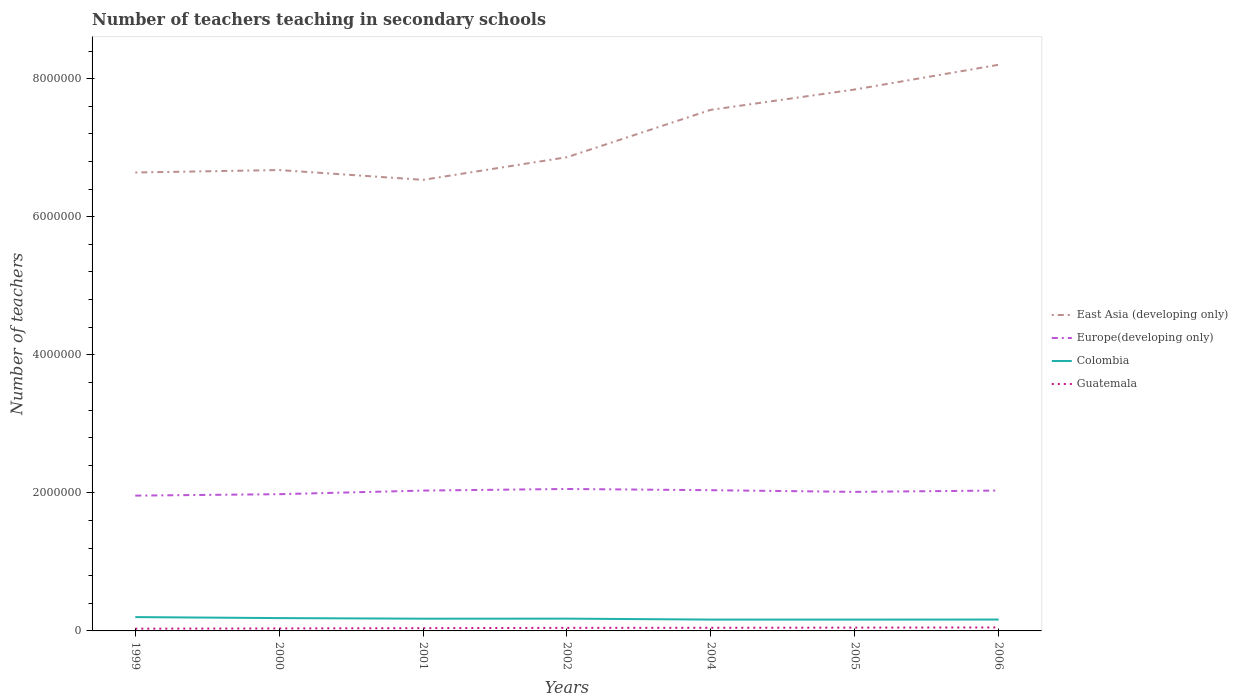Does the line corresponding to Europe(developing only) intersect with the line corresponding to Colombia?
Offer a very short reply. No. Across all years, what is the maximum number of teachers teaching in secondary schools in Colombia?
Keep it short and to the point. 1.64e+05. What is the total number of teachers teaching in secondary schools in Guatemala in the graph?
Your answer should be compact. -9490. What is the difference between the highest and the second highest number of teachers teaching in secondary schools in Guatemala?
Your answer should be compact. 1.71e+04. What is the difference between the highest and the lowest number of teachers teaching in secondary schools in Europe(developing only)?
Your response must be concise. 4. How many lines are there?
Your answer should be very brief. 4. How many years are there in the graph?
Offer a terse response. 7. What is the difference between two consecutive major ticks on the Y-axis?
Your response must be concise. 2.00e+06. Are the values on the major ticks of Y-axis written in scientific E-notation?
Make the answer very short. No. How many legend labels are there?
Your response must be concise. 4. How are the legend labels stacked?
Ensure brevity in your answer.  Vertical. What is the title of the graph?
Make the answer very short. Number of teachers teaching in secondary schools. Does "Middle East & North Africa (all income levels)" appear as one of the legend labels in the graph?
Your answer should be very brief. No. What is the label or title of the X-axis?
Offer a terse response. Years. What is the label or title of the Y-axis?
Your answer should be very brief. Number of teachers. What is the Number of teachers of East Asia (developing only) in 1999?
Offer a terse response. 6.64e+06. What is the Number of teachers of Europe(developing only) in 1999?
Your answer should be compact. 1.96e+06. What is the Number of teachers of Colombia in 1999?
Give a very brief answer. 2.00e+05. What is the Number of teachers in Guatemala in 1999?
Your response must be concise. 3.28e+04. What is the Number of teachers in East Asia (developing only) in 2000?
Provide a succinct answer. 6.68e+06. What is the Number of teachers of Europe(developing only) in 2000?
Offer a very short reply. 1.98e+06. What is the Number of teachers of Colombia in 2000?
Your response must be concise. 1.86e+05. What is the Number of teachers in Guatemala in 2000?
Offer a terse response. 3.59e+04. What is the Number of teachers of East Asia (developing only) in 2001?
Give a very brief answer. 6.53e+06. What is the Number of teachers of Europe(developing only) in 2001?
Provide a succinct answer. 2.03e+06. What is the Number of teachers in Colombia in 2001?
Offer a very short reply. 1.77e+05. What is the Number of teachers in Guatemala in 2001?
Your answer should be compact. 4.00e+04. What is the Number of teachers in East Asia (developing only) in 2002?
Give a very brief answer. 6.86e+06. What is the Number of teachers of Europe(developing only) in 2002?
Your response must be concise. 2.06e+06. What is the Number of teachers in Colombia in 2002?
Keep it short and to the point. 1.78e+05. What is the Number of teachers in Guatemala in 2002?
Offer a very short reply. 4.44e+04. What is the Number of teachers in East Asia (developing only) in 2004?
Keep it short and to the point. 7.55e+06. What is the Number of teachers of Europe(developing only) in 2004?
Provide a short and direct response. 2.04e+06. What is the Number of teachers in Colombia in 2004?
Ensure brevity in your answer.  1.64e+05. What is the Number of teachers of Guatemala in 2004?
Keep it short and to the point. 4.54e+04. What is the Number of teachers of East Asia (developing only) in 2005?
Give a very brief answer. 7.84e+06. What is the Number of teachers in Europe(developing only) in 2005?
Provide a short and direct response. 2.01e+06. What is the Number of teachers in Colombia in 2005?
Offer a terse response. 1.64e+05. What is the Number of teachers in Guatemala in 2005?
Make the answer very short. 4.79e+04. What is the Number of teachers in East Asia (developing only) in 2006?
Provide a short and direct response. 8.20e+06. What is the Number of teachers of Europe(developing only) in 2006?
Keep it short and to the point. 2.03e+06. What is the Number of teachers in Colombia in 2006?
Offer a very short reply. 1.65e+05. What is the Number of teachers of Guatemala in 2006?
Ensure brevity in your answer.  4.99e+04. Across all years, what is the maximum Number of teachers of East Asia (developing only)?
Your response must be concise. 8.20e+06. Across all years, what is the maximum Number of teachers in Europe(developing only)?
Provide a short and direct response. 2.06e+06. Across all years, what is the maximum Number of teachers in Colombia?
Keep it short and to the point. 2.00e+05. Across all years, what is the maximum Number of teachers of Guatemala?
Your answer should be compact. 4.99e+04. Across all years, what is the minimum Number of teachers of East Asia (developing only)?
Offer a terse response. 6.53e+06. Across all years, what is the minimum Number of teachers of Europe(developing only)?
Keep it short and to the point. 1.96e+06. Across all years, what is the minimum Number of teachers of Colombia?
Your answer should be very brief. 1.64e+05. Across all years, what is the minimum Number of teachers of Guatemala?
Keep it short and to the point. 3.28e+04. What is the total Number of teachers of East Asia (developing only) in the graph?
Provide a succinct answer. 5.03e+07. What is the total Number of teachers of Europe(developing only) in the graph?
Your answer should be compact. 1.41e+07. What is the total Number of teachers in Colombia in the graph?
Offer a terse response. 1.23e+06. What is the total Number of teachers in Guatemala in the graph?
Make the answer very short. 2.96e+05. What is the difference between the Number of teachers in East Asia (developing only) in 1999 and that in 2000?
Offer a very short reply. -3.54e+04. What is the difference between the Number of teachers of Europe(developing only) in 1999 and that in 2000?
Keep it short and to the point. -2.05e+04. What is the difference between the Number of teachers of Colombia in 1999 and that in 2000?
Your response must be concise. 1.44e+04. What is the difference between the Number of teachers of Guatemala in 1999 and that in 2000?
Your response must be concise. -3079. What is the difference between the Number of teachers in East Asia (developing only) in 1999 and that in 2001?
Offer a terse response. 1.06e+05. What is the difference between the Number of teachers in Europe(developing only) in 1999 and that in 2001?
Your answer should be very brief. -7.29e+04. What is the difference between the Number of teachers of Colombia in 1999 and that in 2001?
Offer a terse response. 2.32e+04. What is the difference between the Number of teachers of Guatemala in 1999 and that in 2001?
Offer a very short reply. -7198. What is the difference between the Number of teachers in East Asia (developing only) in 1999 and that in 2002?
Your answer should be very brief. -2.21e+05. What is the difference between the Number of teachers in Europe(developing only) in 1999 and that in 2002?
Give a very brief answer. -9.61e+04. What is the difference between the Number of teachers in Colombia in 1999 and that in 2002?
Keep it short and to the point. 2.24e+04. What is the difference between the Number of teachers of Guatemala in 1999 and that in 2002?
Offer a very short reply. -1.16e+04. What is the difference between the Number of teachers in East Asia (developing only) in 1999 and that in 2004?
Keep it short and to the point. -9.08e+05. What is the difference between the Number of teachers of Europe(developing only) in 1999 and that in 2004?
Keep it short and to the point. -7.84e+04. What is the difference between the Number of teachers in Colombia in 1999 and that in 2004?
Make the answer very short. 3.60e+04. What is the difference between the Number of teachers in Guatemala in 1999 and that in 2004?
Your answer should be compact. -1.26e+04. What is the difference between the Number of teachers of East Asia (developing only) in 1999 and that in 2005?
Your response must be concise. -1.20e+06. What is the difference between the Number of teachers in Europe(developing only) in 1999 and that in 2005?
Your answer should be compact. -5.41e+04. What is the difference between the Number of teachers in Colombia in 1999 and that in 2005?
Your answer should be very brief. 3.61e+04. What is the difference between the Number of teachers of Guatemala in 1999 and that in 2005?
Ensure brevity in your answer.  -1.51e+04. What is the difference between the Number of teachers in East Asia (developing only) in 1999 and that in 2006?
Make the answer very short. -1.56e+06. What is the difference between the Number of teachers of Europe(developing only) in 1999 and that in 2006?
Offer a very short reply. -7.34e+04. What is the difference between the Number of teachers of Colombia in 1999 and that in 2006?
Keep it short and to the point. 3.56e+04. What is the difference between the Number of teachers in Guatemala in 1999 and that in 2006?
Keep it short and to the point. -1.71e+04. What is the difference between the Number of teachers in East Asia (developing only) in 2000 and that in 2001?
Give a very brief answer. 1.42e+05. What is the difference between the Number of teachers in Europe(developing only) in 2000 and that in 2001?
Your answer should be very brief. -5.24e+04. What is the difference between the Number of teachers in Colombia in 2000 and that in 2001?
Make the answer very short. 8747. What is the difference between the Number of teachers of Guatemala in 2000 and that in 2001?
Your answer should be compact. -4119. What is the difference between the Number of teachers in East Asia (developing only) in 2000 and that in 2002?
Offer a very short reply. -1.86e+05. What is the difference between the Number of teachers of Europe(developing only) in 2000 and that in 2002?
Provide a short and direct response. -7.56e+04. What is the difference between the Number of teachers of Colombia in 2000 and that in 2002?
Offer a terse response. 7984. What is the difference between the Number of teachers in Guatemala in 2000 and that in 2002?
Offer a terse response. -8525. What is the difference between the Number of teachers of East Asia (developing only) in 2000 and that in 2004?
Offer a very short reply. -8.72e+05. What is the difference between the Number of teachers in Europe(developing only) in 2000 and that in 2004?
Your response must be concise. -5.79e+04. What is the difference between the Number of teachers of Colombia in 2000 and that in 2004?
Provide a short and direct response. 2.16e+04. What is the difference between the Number of teachers of Guatemala in 2000 and that in 2004?
Offer a very short reply. -9490. What is the difference between the Number of teachers of East Asia (developing only) in 2000 and that in 2005?
Provide a succinct answer. -1.17e+06. What is the difference between the Number of teachers of Europe(developing only) in 2000 and that in 2005?
Your response must be concise. -3.36e+04. What is the difference between the Number of teachers in Colombia in 2000 and that in 2005?
Provide a short and direct response. 2.17e+04. What is the difference between the Number of teachers in Guatemala in 2000 and that in 2005?
Offer a terse response. -1.20e+04. What is the difference between the Number of teachers of East Asia (developing only) in 2000 and that in 2006?
Give a very brief answer. -1.53e+06. What is the difference between the Number of teachers of Europe(developing only) in 2000 and that in 2006?
Your answer should be compact. -5.29e+04. What is the difference between the Number of teachers in Colombia in 2000 and that in 2006?
Provide a succinct answer. 2.11e+04. What is the difference between the Number of teachers in Guatemala in 2000 and that in 2006?
Your response must be concise. -1.40e+04. What is the difference between the Number of teachers in East Asia (developing only) in 2001 and that in 2002?
Offer a terse response. -3.28e+05. What is the difference between the Number of teachers of Europe(developing only) in 2001 and that in 2002?
Your response must be concise. -2.32e+04. What is the difference between the Number of teachers in Colombia in 2001 and that in 2002?
Provide a short and direct response. -763. What is the difference between the Number of teachers of Guatemala in 2001 and that in 2002?
Give a very brief answer. -4406. What is the difference between the Number of teachers of East Asia (developing only) in 2001 and that in 2004?
Offer a very short reply. -1.01e+06. What is the difference between the Number of teachers in Europe(developing only) in 2001 and that in 2004?
Your answer should be very brief. -5475. What is the difference between the Number of teachers of Colombia in 2001 and that in 2004?
Give a very brief answer. 1.28e+04. What is the difference between the Number of teachers of Guatemala in 2001 and that in 2004?
Keep it short and to the point. -5371. What is the difference between the Number of teachers in East Asia (developing only) in 2001 and that in 2005?
Ensure brevity in your answer.  -1.31e+06. What is the difference between the Number of teachers of Europe(developing only) in 2001 and that in 2005?
Ensure brevity in your answer.  1.88e+04. What is the difference between the Number of teachers in Colombia in 2001 and that in 2005?
Your answer should be compact. 1.30e+04. What is the difference between the Number of teachers in Guatemala in 2001 and that in 2005?
Ensure brevity in your answer.  -7875. What is the difference between the Number of teachers of East Asia (developing only) in 2001 and that in 2006?
Ensure brevity in your answer.  -1.67e+06. What is the difference between the Number of teachers of Europe(developing only) in 2001 and that in 2006?
Provide a succinct answer. -537.38. What is the difference between the Number of teachers in Colombia in 2001 and that in 2006?
Provide a short and direct response. 1.24e+04. What is the difference between the Number of teachers in Guatemala in 2001 and that in 2006?
Give a very brief answer. -9906. What is the difference between the Number of teachers of East Asia (developing only) in 2002 and that in 2004?
Give a very brief answer. -6.86e+05. What is the difference between the Number of teachers in Europe(developing only) in 2002 and that in 2004?
Your answer should be compact. 1.77e+04. What is the difference between the Number of teachers in Colombia in 2002 and that in 2004?
Your answer should be compact. 1.36e+04. What is the difference between the Number of teachers of Guatemala in 2002 and that in 2004?
Your answer should be very brief. -965. What is the difference between the Number of teachers in East Asia (developing only) in 2002 and that in 2005?
Ensure brevity in your answer.  -9.81e+05. What is the difference between the Number of teachers of Europe(developing only) in 2002 and that in 2005?
Offer a terse response. 4.20e+04. What is the difference between the Number of teachers of Colombia in 2002 and that in 2005?
Offer a very short reply. 1.37e+04. What is the difference between the Number of teachers in Guatemala in 2002 and that in 2005?
Offer a very short reply. -3469. What is the difference between the Number of teachers in East Asia (developing only) in 2002 and that in 2006?
Keep it short and to the point. -1.34e+06. What is the difference between the Number of teachers of Europe(developing only) in 2002 and that in 2006?
Keep it short and to the point. 2.27e+04. What is the difference between the Number of teachers in Colombia in 2002 and that in 2006?
Give a very brief answer. 1.32e+04. What is the difference between the Number of teachers of Guatemala in 2002 and that in 2006?
Keep it short and to the point. -5500. What is the difference between the Number of teachers in East Asia (developing only) in 2004 and that in 2005?
Your response must be concise. -2.94e+05. What is the difference between the Number of teachers in Europe(developing only) in 2004 and that in 2005?
Your answer should be compact. 2.42e+04. What is the difference between the Number of teachers of Colombia in 2004 and that in 2005?
Your answer should be compact. 146. What is the difference between the Number of teachers in Guatemala in 2004 and that in 2005?
Keep it short and to the point. -2504. What is the difference between the Number of teachers in East Asia (developing only) in 2004 and that in 2006?
Give a very brief answer. -6.53e+05. What is the difference between the Number of teachers of Europe(developing only) in 2004 and that in 2006?
Provide a short and direct response. 4937.62. What is the difference between the Number of teachers of Colombia in 2004 and that in 2006?
Offer a very short reply. -443. What is the difference between the Number of teachers in Guatemala in 2004 and that in 2006?
Offer a terse response. -4535. What is the difference between the Number of teachers in East Asia (developing only) in 2005 and that in 2006?
Keep it short and to the point. -3.58e+05. What is the difference between the Number of teachers of Europe(developing only) in 2005 and that in 2006?
Provide a short and direct response. -1.93e+04. What is the difference between the Number of teachers of Colombia in 2005 and that in 2006?
Your answer should be very brief. -589. What is the difference between the Number of teachers in Guatemala in 2005 and that in 2006?
Ensure brevity in your answer.  -2031. What is the difference between the Number of teachers in East Asia (developing only) in 1999 and the Number of teachers in Europe(developing only) in 2000?
Make the answer very short. 4.66e+06. What is the difference between the Number of teachers in East Asia (developing only) in 1999 and the Number of teachers in Colombia in 2000?
Your answer should be very brief. 6.45e+06. What is the difference between the Number of teachers in East Asia (developing only) in 1999 and the Number of teachers in Guatemala in 2000?
Make the answer very short. 6.60e+06. What is the difference between the Number of teachers in Europe(developing only) in 1999 and the Number of teachers in Colombia in 2000?
Offer a very short reply. 1.77e+06. What is the difference between the Number of teachers of Europe(developing only) in 1999 and the Number of teachers of Guatemala in 2000?
Keep it short and to the point. 1.92e+06. What is the difference between the Number of teachers in Colombia in 1999 and the Number of teachers in Guatemala in 2000?
Make the answer very short. 1.64e+05. What is the difference between the Number of teachers of East Asia (developing only) in 1999 and the Number of teachers of Europe(developing only) in 2001?
Ensure brevity in your answer.  4.61e+06. What is the difference between the Number of teachers in East Asia (developing only) in 1999 and the Number of teachers in Colombia in 2001?
Offer a very short reply. 6.46e+06. What is the difference between the Number of teachers of East Asia (developing only) in 1999 and the Number of teachers of Guatemala in 2001?
Provide a short and direct response. 6.60e+06. What is the difference between the Number of teachers in Europe(developing only) in 1999 and the Number of teachers in Colombia in 2001?
Give a very brief answer. 1.78e+06. What is the difference between the Number of teachers in Europe(developing only) in 1999 and the Number of teachers in Guatemala in 2001?
Keep it short and to the point. 1.92e+06. What is the difference between the Number of teachers in Colombia in 1999 and the Number of teachers in Guatemala in 2001?
Your answer should be compact. 1.60e+05. What is the difference between the Number of teachers of East Asia (developing only) in 1999 and the Number of teachers of Europe(developing only) in 2002?
Give a very brief answer. 4.58e+06. What is the difference between the Number of teachers of East Asia (developing only) in 1999 and the Number of teachers of Colombia in 2002?
Offer a very short reply. 6.46e+06. What is the difference between the Number of teachers of East Asia (developing only) in 1999 and the Number of teachers of Guatemala in 2002?
Ensure brevity in your answer.  6.60e+06. What is the difference between the Number of teachers in Europe(developing only) in 1999 and the Number of teachers in Colombia in 2002?
Provide a succinct answer. 1.78e+06. What is the difference between the Number of teachers of Europe(developing only) in 1999 and the Number of teachers of Guatemala in 2002?
Keep it short and to the point. 1.92e+06. What is the difference between the Number of teachers of Colombia in 1999 and the Number of teachers of Guatemala in 2002?
Your answer should be compact. 1.56e+05. What is the difference between the Number of teachers of East Asia (developing only) in 1999 and the Number of teachers of Europe(developing only) in 2004?
Ensure brevity in your answer.  4.60e+06. What is the difference between the Number of teachers in East Asia (developing only) in 1999 and the Number of teachers in Colombia in 2004?
Your answer should be very brief. 6.48e+06. What is the difference between the Number of teachers in East Asia (developing only) in 1999 and the Number of teachers in Guatemala in 2004?
Give a very brief answer. 6.60e+06. What is the difference between the Number of teachers in Europe(developing only) in 1999 and the Number of teachers in Colombia in 2004?
Provide a short and direct response. 1.80e+06. What is the difference between the Number of teachers in Europe(developing only) in 1999 and the Number of teachers in Guatemala in 2004?
Offer a terse response. 1.91e+06. What is the difference between the Number of teachers of Colombia in 1999 and the Number of teachers of Guatemala in 2004?
Provide a short and direct response. 1.55e+05. What is the difference between the Number of teachers in East Asia (developing only) in 1999 and the Number of teachers in Europe(developing only) in 2005?
Ensure brevity in your answer.  4.63e+06. What is the difference between the Number of teachers of East Asia (developing only) in 1999 and the Number of teachers of Colombia in 2005?
Your response must be concise. 6.48e+06. What is the difference between the Number of teachers in East Asia (developing only) in 1999 and the Number of teachers in Guatemala in 2005?
Provide a succinct answer. 6.59e+06. What is the difference between the Number of teachers in Europe(developing only) in 1999 and the Number of teachers in Colombia in 2005?
Provide a short and direct response. 1.80e+06. What is the difference between the Number of teachers in Europe(developing only) in 1999 and the Number of teachers in Guatemala in 2005?
Offer a very short reply. 1.91e+06. What is the difference between the Number of teachers of Colombia in 1999 and the Number of teachers of Guatemala in 2005?
Provide a succinct answer. 1.52e+05. What is the difference between the Number of teachers in East Asia (developing only) in 1999 and the Number of teachers in Europe(developing only) in 2006?
Ensure brevity in your answer.  4.61e+06. What is the difference between the Number of teachers of East Asia (developing only) in 1999 and the Number of teachers of Colombia in 2006?
Offer a terse response. 6.48e+06. What is the difference between the Number of teachers in East Asia (developing only) in 1999 and the Number of teachers in Guatemala in 2006?
Make the answer very short. 6.59e+06. What is the difference between the Number of teachers of Europe(developing only) in 1999 and the Number of teachers of Colombia in 2006?
Your response must be concise. 1.80e+06. What is the difference between the Number of teachers in Europe(developing only) in 1999 and the Number of teachers in Guatemala in 2006?
Your response must be concise. 1.91e+06. What is the difference between the Number of teachers in Colombia in 1999 and the Number of teachers in Guatemala in 2006?
Provide a short and direct response. 1.50e+05. What is the difference between the Number of teachers of East Asia (developing only) in 2000 and the Number of teachers of Europe(developing only) in 2001?
Keep it short and to the point. 4.64e+06. What is the difference between the Number of teachers of East Asia (developing only) in 2000 and the Number of teachers of Colombia in 2001?
Keep it short and to the point. 6.50e+06. What is the difference between the Number of teachers in East Asia (developing only) in 2000 and the Number of teachers in Guatemala in 2001?
Your answer should be compact. 6.64e+06. What is the difference between the Number of teachers of Europe(developing only) in 2000 and the Number of teachers of Colombia in 2001?
Your response must be concise. 1.80e+06. What is the difference between the Number of teachers of Europe(developing only) in 2000 and the Number of teachers of Guatemala in 2001?
Make the answer very short. 1.94e+06. What is the difference between the Number of teachers of Colombia in 2000 and the Number of teachers of Guatemala in 2001?
Your answer should be compact. 1.46e+05. What is the difference between the Number of teachers of East Asia (developing only) in 2000 and the Number of teachers of Europe(developing only) in 2002?
Keep it short and to the point. 4.62e+06. What is the difference between the Number of teachers in East Asia (developing only) in 2000 and the Number of teachers in Colombia in 2002?
Provide a short and direct response. 6.50e+06. What is the difference between the Number of teachers in East Asia (developing only) in 2000 and the Number of teachers in Guatemala in 2002?
Your answer should be compact. 6.63e+06. What is the difference between the Number of teachers of Europe(developing only) in 2000 and the Number of teachers of Colombia in 2002?
Provide a succinct answer. 1.80e+06. What is the difference between the Number of teachers of Europe(developing only) in 2000 and the Number of teachers of Guatemala in 2002?
Your answer should be compact. 1.94e+06. What is the difference between the Number of teachers of Colombia in 2000 and the Number of teachers of Guatemala in 2002?
Your answer should be very brief. 1.41e+05. What is the difference between the Number of teachers in East Asia (developing only) in 2000 and the Number of teachers in Europe(developing only) in 2004?
Offer a terse response. 4.64e+06. What is the difference between the Number of teachers in East Asia (developing only) in 2000 and the Number of teachers in Colombia in 2004?
Keep it short and to the point. 6.51e+06. What is the difference between the Number of teachers in East Asia (developing only) in 2000 and the Number of teachers in Guatemala in 2004?
Your answer should be very brief. 6.63e+06. What is the difference between the Number of teachers in Europe(developing only) in 2000 and the Number of teachers in Colombia in 2004?
Keep it short and to the point. 1.82e+06. What is the difference between the Number of teachers of Europe(developing only) in 2000 and the Number of teachers of Guatemala in 2004?
Provide a succinct answer. 1.94e+06. What is the difference between the Number of teachers of Colombia in 2000 and the Number of teachers of Guatemala in 2004?
Give a very brief answer. 1.41e+05. What is the difference between the Number of teachers of East Asia (developing only) in 2000 and the Number of teachers of Europe(developing only) in 2005?
Your answer should be compact. 4.66e+06. What is the difference between the Number of teachers in East Asia (developing only) in 2000 and the Number of teachers in Colombia in 2005?
Give a very brief answer. 6.51e+06. What is the difference between the Number of teachers in East Asia (developing only) in 2000 and the Number of teachers in Guatemala in 2005?
Your response must be concise. 6.63e+06. What is the difference between the Number of teachers in Europe(developing only) in 2000 and the Number of teachers in Colombia in 2005?
Make the answer very short. 1.82e+06. What is the difference between the Number of teachers in Europe(developing only) in 2000 and the Number of teachers in Guatemala in 2005?
Keep it short and to the point. 1.93e+06. What is the difference between the Number of teachers in Colombia in 2000 and the Number of teachers in Guatemala in 2005?
Offer a very short reply. 1.38e+05. What is the difference between the Number of teachers in East Asia (developing only) in 2000 and the Number of teachers in Europe(developing only) in 2006?
Make the answer very short. 4.64e+06. What is the difference between the Number of teachers in East Asia (developing only) in 2000 and the Number of teachers in Colombia in 2006?
Make the answer very short. 6.51e+06. What is the difference between the Number of teachers in East Asia (developing only) in 2000 and the Number of teachers in Guatemala in 2006?
Offer a terse response. 6.63e+06. What is the difference between the Number of teachers of Europe(developing only) in 2000 and the Number of teachers of Colombia in 2006?
Make the answer very short. 1.82e+06. What is the difference between the Number of teachers in Europe(developing only) in 2000 and the Number of teachers in Guatemala in 2006?
Offer a terse response. 1.93e+06. What is the difference between the Number of teachers of Colombia in 2000 and the Number of teachers of Guatemala in 2006?
Provide a succinct answer. 1.36e+05. What is the difference between the Number of teachers of East Asia (developing only) in 2001 and the Number of teachers of Europe(developing only) in 2002?
Give a very brief answer. 4.48e+06. What is the difference between the Number of teachers in East Asia (developing only) in 2001 and the Number of teachers in Colombia in 2002?
Ensure brevity in your answer.  6.36e+06. What is the difference between the Number of teachers of East Asia (developing only) in 2001 and the Number of teachers of Guatemala in 2002?
Give a very brief answer. 6.49e+06. What is the difference between the Number of teachers in Europe(developing only) in 2001 and the Number of teachers in Colombia in 2002?
Ensure brevity in your answer.  1.86e+06. What is the difference between the Number of teachers in Europe(developing only) in 2001 and the Number of teachers in Guatemala in 2002?
Provide a short and direct response. 1.99e+06. What is the difference between the Number of teachers in Colombia in 2001 and the Number of teachers in Guatemala in 2002?
Your answer should be very brief. 1.33e+05. What is the difference between the Number of teachers in East Asia (developing only) in 2001 and the Number of teachers in Europe(developing only) in 2004?
Ensure brevity in your answer.  4.50e+06. What is the difference between the Number of teachers of East Asia (developing only) in 2001 and the Number of teachers of Colombia in 2004?
Make the answer very short. 6.37e+06. What is the difference between the Number of teachers of East Asia (developing only) in 2001 and the Number of teachers of Guatemala in 2004?
Offer a terse response. 6.49e+06. What is the difference between the Number of teachers in Europe(developing only) in 2001 and the Number of teachers in Colombia in 2004?
Keep it short and to the point. 1.87e+06. What is the difference between the Number of teachers in Europe(developing only) in 2001 and the Number of teachers in Guatemala in 2004?
Your answer should be very brief. 1.99e+06. What is the difference between the Number of teachers in Colombia in 2001 and the Number of teachers in Guatemala in 2004?
Make the answer very short. 1.32e+05. What is the difference between the Number of teachers in East Asia (developing only) in 2001 and the Number of teachers in Europe(developing only) in 2005?
Make the answer very short. 4.52e+06. What is the difference between the Number of teachers in East Asia (developing only) in 2001 and the Number of teachers in Colombia in 2005?
Your response must be concise. 6.37e+06. What is the difference between the Number of teachers of East Asia (developing only) in 2001 and the Number of teachers of Guatemala in 2005?
Offer a very short reply. 6.49e+06. What is the difference between the Number of teachers in Europe(developing only) in 2001 and the Number of teachers in Colombia in 2005?
Your answer should be compact. 1.87e+06. What is the difference between the Number of teachers in Europe(developing only) in 2001 and the Number of teachers in Guatemala in 2005?
Give a very brief answer. 1.99e+06. What is the difference between the Number of teachers in Colombia in 2001 and the Number of teachers in Guatemala in 2005?
Provide a succinct answer. 1.29e+05. What is the difference between the Number of teachers of East Asia (developing only) in 2001 and the Number of teachers of Europe(developing only) in 2006?
Provide a succinct answer. 4.50e+06. What is the difference between the Number of teachers of East Asia (developing only) in 2001 and the Number of teachers of Colombia in 2006?
Your response must be concise. 6.37e+06. What is the difference between the Number of teachers in East Asia (developing only) in 2001 and the Number of teachers in Guatemala in 2006?
Keep it short and to the point. 6.48e+06. What is the difference between the Number of teachers in Europe(developing only) in 2001 and the Number of teachers in Colombia in 2006?
Provide a succinct answer. 1.87e+06. What is the difference between the Number of teachers of Europe(developing only) in 2001 and the Number of teachers of Guatemala in 2006?
Offer a terse response. 1.98e+06. What is the difference between the Number of teachers of Colombia in 2001 and the Number of teachers of Guatemala in 2006?
Your answer should be compact. 1.27e+05. What is the difference between the Number of teachers in East Asia (developing only) in 2002 and the Number of teachers in Europe(developing only) in 2004?
Your answer should be compact. 4.82e+06. What is the difference between the Number of teachers in East Asia (developing only) in 2002 and the Number of teachers in Colombia in 2004?
Your answer should be very brief. 6.70e+06. What is the difference between the Number of teachers of East Asia (developing only) in 2002 and the Number of teachers of Guatemala in 2004?
Make the answer very short. 6.82e+06. What is the difference between the Number of teachers in Europe(developing only) in 2002 and the Number of teachers in Colombia in 2004?
Provide a short and direct response. 1.89e+06. What is the difference between the Number of teachers of Europe(developing only) in 2002 and the Number of teachers of Guatemala in 2004?
Your answer should be compact. 2.01e+06. What is the difference between the Number of teachers in Colombia in 2002 and the Number of teachers in Guatemala in 2004?
Keep it short and to the point. 1.33e+05. What is the difference between the Number of teachers of East Asia (developing only) in 2002 and the Number of teachers of Europe(developing only) in 2005?
Your answer should be very brief. 4.85e+06. What is the difference between the Number of teachers in East Asia (developing only) in 2002 and the Number of teachers in Colombia in 2005?
Offer a very short reply. 6.70e+06. What is the difference between the Number of teachers in East Asia (developing only) in 2002 and the Number of teachers in Guatemala in 2005?
Keep it short and to the point. 6.81e+06. What is the difference between the Number of teachers of Europe(developing only) in 2002 and the Number of teachers of Colombia in 2005?
Your answer should be compact. 1.89e+06. What is the difference between the Number of teachers in Europe(developing only) in 2002 and the Number of teachers in Guatemala in 2005?
Your response must be concise. 2.01e+06. What is the difference between the Number of teachers in Colombia in 2002 and the Number of teachers in Guatemala in 2005?
Your answer should be very brief. 1.30e+05. What is the difference between the Number of teachers in East Asia (developing only) in 2002 and the Number of teachers in Europe(developing only) in 2006?
Make the answer very short. 4.83e+06. What is the difference between the Number of teachers of East Asia (developing only) in 2002 and the Number of teachers of Colombia in 2006?
Make the answer very short. 6.70e+06. What is the difference between the Number of teachers in East Asia (developing only) in 2002 and the Number of teachers in Guatemala in 2006?
Offer a terse response. 6.81e+06. What is the difference between the Number of teachers in Europe(developing only) in 2002 and the Number of teachers in Colombia in 2006?
Provide a succinct answer. 1.89e+06. What is the difference between the Number of teachers in Europe(developing only) in 2002 and the Number of teachers in Guatemala in 2006?
Offer a very short reply. 2.01e+06. What is the difference between the Number of teachers in Colombia in 2002 and the Number of teachers in Guatemala in 2006?
Keep it short and to the point. 1.28e+05. What is the difference between the Number of teachers of East Asia (developing only) in 2004 and the Number of teachers of Europe(developing only) in 2005?
Make the answer very short. 5.53e+06. What is the difference between the Number of teachers of East Asia (developing only) in 2004 and the Number of teachers of Colombia in 2005?
Give a very brief answer. 7.38e+06. What is the difference between the Number of teachers in East Asia (developing only) in 2004 and the Number of teachers in Guatemala in 2005?
Your answer should be compact. 7.50e+06. What is the difference between the Number of teachers in Europe(developing only) in 2004 and the Number of teachers in Colombia in 2005?
Offer a very short reply. 1.87e+06. What is the difference between the Number of teachers in Europe(developing only) in 2004 and the Number of teachers in Guatemala in 2005?
Make the answer very short. 1.99e+06. What is the difference between the Number of teachers in Colombia in 2004 and the Number of teachers in Guatemala in 2005?
Give a very brief answer. 1.16e+05. What is the difference between the Number of teachers in East Asia (developing only) in 2004 and the Number of teachers in Europe(developing only) in 2006?
Your answer should be compact. 5.51e+06. What is the difference between the Number of teachers of East Asia (developing only) in 2004 and the Number of teachers of Colombia in 2006?
Make the answer very short. 7.38e+06. What is the difference between the Number of teachers of East Asia (developing only) in 2004 and the Number of teachers of Guatemala in 2006?
Provide a succinct answer. 7.50e+06. What is the difference between the Number of teachers of Europe(developing only) in 2004 and the Number of teachers of Colombia in 2006?
Offer a very short reply. 1.87e+06. What is the difference between the Number of teachers of Europe(developing only) in 2004 and the Number of teachers of Guatemala in 2006?
Give a very brief answer. 1.99e+06. What is the difference between the Number of teachers in Colombia in 2004 and the Number of teachers in Guatemala in 2006?
Make the answer very short. 1.14e+05. What is the difference between the Number of teachers in East Asia (developing only) in 2005 and the Number of teachers in Europe(developing only) in 2006?
Your answer should be compact. 5.81e+06. What is the difference between the Number of teachers of East Asia (developing only) in 2005 and the Number of teachers of Colombia in 2006?
Make the answer very short. 7.68e+06. What is the difference between the Number of teachers in East Asia (developing only) in 2005 and the Number of teachers in Guatemala in 2006?
Your answer should be very brief. 7.79e+06. What is the difference between the Number of teachers of Europe(developing only) in 2005 and the Number of teachers of Colombia in 2006?
Ensure brevity in your answer.  1.85e+06. What is the difference between the Number of teachers in Europe(developing only) in 2005 and the Number of teachers in Guatemala in 2006?
Your answer should be very brief. 1.96e+06. What is the difference between the Number of teachers in Colombia in 2005 and the Number of teachers in Guatemala in 2006?
Your answer should be compact. 1.14e+05. What is the average Number of teachers in East Asia (developing only) per year?
Ensure brevity in your answer.  7.19e+06. What is the average Number of teachers of Europe(developing only) per year?
Ensure brevity in your answer.  2.02e+06. What is the average Number of teachers of Colombia per year?
Your response must be concise. 1.76e+05. What is the average Number of teachers of Guatemala per year?
Make the answer very short. 4.23e+04. In the year 1999, what is the difference between the Number of teachers of East Asia (developing only) and Number of teachers of Europe(developing only)?
Your answer should be very brief. 4.68e+06. In the year 1999, what is the difference between the Number of teachers of East Asia (developing only) and Number of teachers of Colombia?
Provide a succinct answer. 6.44e+06. In the year 1999, what is the difference between the Number of teachers of East Asia (developing only) and Number of teachers of Guatemala?
Your answer should be compact. 6.61e+06. In the year 1999, what is the difference between the Number of teachers in Europe(developing only) and Number of teachers in Colombia?
Provide a short and direct response. 1.76e+06. In the year 1999, what is the difference between the Number of teachers of Europe(developing only) and Number of teachers of Guatemala?
Offer a very short reply. 1.93e+06. In the year 1999, what is the difference between the Number of teachers in Colombia and Number of teachers in Guatemala?
Your answer should be compact. 1.68e+05. In the year 2000, what is the difference between the Number of teachers in East Asia (developing only) and Number of teachers in Europe(developing only)?
Provide a short and direct response. 4.70e+06. In the year 2000, what is the difference between the Number of teachers in East Asia (developing only) and Number of teachers in Colombia?
Provide a succinct answer. 6.49e+06. In the year 2000, what is the difference between the Number of teachers in East Asia (developing only) and Number of teachers in Guatemala?
Make the answer very short. 6.64e+06. In the year 2000, what is the difference between the Number of teachers in Europe(developing only) and Number of teachers in Colombia?
Your answer should be compact. 1.79e+06. In the year 2000, what is the difference between the Number of teachers of Europe(developing only) and Number of teachers of Guatemala?
Offer a very short reply. 1.94e+06. In the year 2000, what is the difference between the Number of teachers in Colombia and Number of teachers in Guatemala?
Make the answer very short. 1.50e+05. In the year 2001, what is the difference between the Number of teachers in East Asia (developing only) and Number of teachers in Europe(developing only)?
Provide a short and direct response. 4.50e+06. In the year 2001, what is the difference between the Number of teachers of East Asia (developing only) and Number of teachers of Colombia?
Give a very brief answer. 6.36e+06. In the year 2001, what is the difference between the Number of teachers of East Asia (developing only) and Number of teachers of Guatemala?
Your response must be concise. 6.49e+06. In the year 2001, what is the difference between the Number of teachers in Europe(developing only) and Number of teachers in Colombia?
Give a very brief answer. 1.86e+06. In the year 2001, what is the difference between the Number of teachers of Europe(developing only) and Number of teachers of Guatemala?
Your answer should be very brief. 1.99e+06. In the year 2001, what is the difference between the Number of teachers of Colombia and Number of teachers of Guatemala?
Ensure brevity in your answer.  1.37e+05. In the year 2002, what is the difference between the Number of teachers in East Asia (developing only) and Number of teachers in Europe(developing only)?
Keep it short and to the point. 4.81e+06. In the year 2002, what is the difference between the Number of teachers of East Asia (developing only) and Number of teachers of Colombia?
Make the answer very short. 6.68e+06. In the year 2002, what is the difference between the Number of teachers in East Asia (developing only) and Number of teachers in Guatemala?
Your answer should be very brief. 6.82e+06. In the year 2002, what is the difference between the Number of teachers of Europe(developing only) and Number of teachers of Colombia?
Your answer should be very brief. 1.88e+06. In the year 2002, what is the difference between the Number of teachers of Europe(developing only) and Number of teachers of Guatemala?
Your answer should be compact. 2.01e+06. In the year 2002, what is the difference between the Number of teachers in Colombia and Number of teachers in Guatemala?
Offer a terse response. 1.34e+05. In the year 2004, what is the difference between the Number of teachers in East Asia (developing only) and Number of teachers in Europe(developing only)?
Provide a succinct answer. 5.51e+06. In the year 2004, what is the difference between the Number of teachers of East Asia (developing only) and Number of teachers of Colombia?
Ensure brevity in your answer.  7.38e+06. In the year 2004, what is the difference between the Number of teachers in East Asia (developing only) and Number of teachers in Guatemala?
Provide a short and direct response. 7.50e+06. In the year 2004, what is the difference between the Number of teachers in Europe(developing only) and Number of teachers in Colombia?
Keep it short and to the point. 1.87e+06. In the year 2004, what is the difference between the Number of teachers of Europe(developing only) and Number of teachers of Guatemala?
Provide a succinct answer. 1.99e+06. In the year 2004, what is the difference between the Number of teachers in Colombia and Number of teachers in Guatemala?
Provide a succinct answer. 1.19e+05. In the year 2005, what is the difference between the Number of teachers in East Asia (developing only) and Number of teachers in Europe(developing only)?
Give a very brief answer. 5.83e+06. In the year 2005, what is the difference between the Number of teachers in East Asia (developing only) and Number of teachers in Colombia?
Provide a short and direct response. 7.68e+06. In the year 2005, what is the difference between the Number of teachers of East Asia (developing only) and Number of teachers of Guatemala?
Give a very brief answer. 7.79e+06. In the year 2005, what is the difference between the Number of teachers of Europe(developing only) and Number of teachers of Colombia?
Your response must be concise. 1.85e+06. In the year 2005, what is the difference between the Number of teachers in Europe(developing only) and Number of teachers in Guatemala?
Offer a very short reply. 1.97e+06. In the year 2005, what is the difference between the Number of teachers of Colombia and Number of teachers of Guatemala?
Offer a terse response. 1.16e+05. In the year 2006, what is the difference between the Number of teachers of East Asia (developing only) and Number of teachers of Europe(developing only)?
Provide a short and direct response. 6.17e+06. In the year 2006, what is the difference between the Number of teachers in East Asia (developing only) and Number of teachers in Colombia?
Provide a short and direct response. 8.04e+06. In the year 2006, what is the difference between the Number of teachers of East Asia (developing only) and Number of teachers of Guatemala?
Your answer should be very brief. 8.15e+06. In the year 2006, what is the difference between the Number of teachers of Europe(developing only) and Number of teachers of Colombia?
Give a very brief answer. 1.87e+06. In the year 2006, what is the difference between the Number of teachers of Europe(developing only) and Number of teachers of Guatemala?
Offer a very short reply. 1.98e+06. In the year 2006, what is the difference between the Number of teachers of Colombia and Number of teachers of Guatemala?
Your answer should be compact. 1.15e+05. What is the ratio of the Number of teachers in Europe(developing only) in 1999 to that in 2000?
Your answer should be very brief. 0.99. What is the ratio of the Number of teachers in Colombia in 1999 to that in 2000?
Make the answer very short. 1.08. What is the ratio of the Number of teachers in Guatemala in 1999 to that in 2000?
Your answer should be compact. 0.91. What is the ratio of the Number of teachers in East Asia (developing only) in 1999 to that in 2001?
Give a very brief answer. 1.02. What is the ratio of the Number of teachers in Europe(developing only) in 1999 to that in 2001?
Give a very brief answer. 0.96. What is the ratio of the Number of teachers of Colombia in 1999 to that in 2001?
Your answer should be compact. 1.13. What is the ratio of the Number of teachers of Guatemala in 1999 to that in 2001?
Your answer should be compact. 0.82. What is the ratio of the Number of teachers of Europe(developing only) in 1999 to that in 2002?
Your answer should be compact. 0.95. What is the ratio of the Number of teachers in Colombia in 1999 to that in 2002?
Your answer should be compact. 1.13. What is the ratio of the Number of teachers of Guatemala in 1999 to that in 2002?
Make the answer very short. 0.74. What is the ratio of the Number of teachers in East Asia (developing only) in 1999 to that in 2004?
Your answer should be very brief. 0.88. What is the ratio of the Number of teachers of Europe(developing only) in 1999 to that in 2004?
Ensure brevity in your answer.  0.96. What is the ratio of the Number of teachers of Colombia in 1999 to that in 2004?
Your answer should be very brief. 1.22. What is the ratio of the Number of teachers in Guatemala in 1999 to that in 2004?
Keep it short and to the point. 0.72. What is the ratio of the Number of teachers of East Asia (developing only) in 1999 to that in 2005?
Keep it short and to the point. 0.85. What is the ratio of the Number of teachers of Europe(developing only) in 1999 to that in 2005?
Offer a terse response. 0.97. What is the ratio of the Number of teachers in Colombia in 1999 to that in 2005?
Ensure brevity in your answer.  1.22. What is the ratio of the Number of teachers in Guatemala in 1999 to that in 2005?
Offer a very short reply. 0.69. What is the ratio of the Number of teachers in East Asia (developing only) in 1999 to that in 2006?
Provide a succinct answer. 0.81. What is the ratio of the Number of teachers in Europe(developing only) in 1999 to that in 2006?
Offer a very short reply. 0.96. What is the ratio of the Number of teachers in Colombia in 1999 to that in 2006?
Your response must be concise. 1.22. What is the ratio of the Number of teachers of Guatemala in 1999 to that in 2006?
Offer a terse response. 0.66. What is the ratio of the Number of teachers in East Asia (developing only) in 2000 to that in 2001?
Keep it short and to the point. 1.02. What is the ratio of the Number of teachers of Europe(developing only) in 2000 to that in 2001?
Offer a terse response. 0.97. What is the ratio of the Number of teachers in Colombia in 2000 to that in 2001?
Keep it short and to the point. 1.05. What is the ratio of the Number of teachers in Guatemala in 2000 to that in 2001?
Offer a terse response. 0.9. What is the ratio of the Number of teachers of East Asia (developing only) in 2000 to that in 2002?
Your answer should be very brief. 0.97. What is the ratio of the Number of teachers in Europe(developing only) in 2000 to that in 2002?
Keep it short and to the point. 0.96. What is the ratio of the Number of teachers in Colombia in 2000 to that in 2002?
Offer a very short reply. 1.04. What is the ratio of the Number of teachers of Guatemala in 2000 to that in 2002?
Provide a short and direct response. 0.81. What is the ratio of the Number of teachers in East Asia (developing only) in 2000 to that in 2004?
Give a very brief answer. 0.88. What is the ratio of the Number of teachers in Europe(developing only) in 2000 to that in 2004?
Make the answer very short. 0.97. What is the ratio of the Number of teachers of Colombia in 2000 to that in 2004?
Offer a terse response. 1.13. What is the ratio of the Number of teachers of Guatemala in 2000 to that in 2004?
Your response must be concise. 0.79. What is the ratio of the Number of teachers in East Asia (developing only) in 2000 to that in 2005?
Keep it short and to the point. 0.85. What is the ratio of the Number of teachers in Europe(developing only) in 2000 to that in 2005?
Your answer should be very brief. 0.98. What is the ratio of the Number of teachers in Colombia in 2000 to that in 2005?
Offer a very short reply. 1.13. What is the ratio of the Number of teachers in Guatemala in 2000 to that in 2005?
Ensure brevity in your answer.  0.75. What is the ratio of the Number of teachers of East Asia (developing only) in 2000 to that in 2006?
Your response must be concise. 0.81. What is the ratio of the Number of teachers of Colombia in 2000 to that in 2006?
Your answer should be very brief. 1.13. What is the ratio of the Number of teachers in Guatemala in 2000 to that in 2006?
Provide a short and direct response. 0.72. What is the ratio of the Number of teachers of East Asia (developing only) in 2001 to that in 2002?
Ensure brevity in your answer.  0.95. What is the ratio of the Number of teachers of Europe(developing only) in 2001 to that in 2002?
Keep it short and to the point. 0.99. What is the ratio of the Number of teachers of Colombia in 2001 to that in 2002?
Provide a succinct answer. 1. What is the ratio of the Number of teachers of Guatemala in 2001 to that in 2002?
Provide a short and direct response. 0.9. What is the ratio of the Number of teachers of East Asia (developing only) in 2001 to that in 2004?
Give a very brief answer. 0.87. What is the ratio of the Number of teachers of Colombia in 2001 to that in 2004?
Offer a terse response. 1.08. What is the ratio of the Number of teachers of Guatemala in 2001 to that in 2004?
Your answer should be compact. 0.88. What is the ratio of the Number of teachers of East Asia (developing only) in 2001 to that in 2005?
Make the answer very short. 0.83. What is the ratio of the Number of teachers of Europe(developing only) in 2001 to that in 2005?
Keep it short and to the point. 1.01. What is the ratio of the Number of teachers in Colombia in 2001 to that in 2005?
Give a very brief answer. 1.08. What is the ratio of the Number of teachers of Guatemala in 2001 to that in 2005?
Provide a short and direct response. 0.84. What is the ratio of the Number of teachers of East Asia (developing only) in 2001 to that in 2006?
Your response must be concise. 0.8. What is the ratio of the Number of teachers in Europe(developing only) in 2001 to that in 2006?
Offer a very short reply. 1. What is the ratio of the Number of teachers in Colombia in 2001 to that in 2006?
Ensure brevity in your answer.  1.08. What is the ratio of the Number of teachers of Guatemala in 2001 to that in 2006?
Your response must be concise. 0.8. What is the ratio of the Number of teachers of Europe(developing only) in 2002 to that in 2004?
Offer a very short reply. 1.01. What is the ratio of the Number of teachers of Colombia in 2002 to that in 2004?
Provide a short and direct response. 1.08. What is the ratio of the Number of teachers in Guatemala in 2002 to that in 2004?
Offer a terse response. 0.98. What is the ratio of the Number of teachers in East Asia (developing only) in 2002 to that in 2005?
Offer a very short reply. 0.87. What is the ratio of the Number of teachers of Europe(developing only) in 2002 to that in 2005?
Ensure brevity in your answer.  1.02. What is the ratio of the Number of teachers in Colombia in 2002 to that in 2005?
Ensure brevity in your answer.  1.08. What is the ratio of the Number of teachers in Guatemala in 2002 to that in 2005?
Offer a terse response. 0.93. What is the ratio of the Number of teachers of East Asia (developing only) in 2002 to that in 2006?
Your answer should be compact. 0.84. What is the ratio of the Number of teachers of Europe(developing only) in 2002 to that in 2006?
Your answer should be compact. 1.01. What is the ratio of the Number of teachers in Colombia in 2002 to that in 2006?
Offer a terse response. 1.08. What is the ratio of the Number of teachers in Guatemala in 2002 to that in 2006?
Provide a succinct answer. 0.89. What is the ratio of the Number of teachers in East Asia (developing only) in 2004 to that in 2005?
Make the answer very short. 0.96. What is the ratio of the Number of teachers in Europe(developing only) in 2004 to that in 2005?
Your answer should be compact. 1.01. What is the ratio of the Number of teachers in Guatemala in 2004 to that in 2005?
Provide a short and direct response. 0.95. What is the ratio of the Number of teachers of East Asia (developing only) in 2004 to that in 2006?
Provide a succinct answer. 0.92. What is the ratio of the Number of teachers of Europe(developing only) in 2004 to that in 2006?
Provide a short and direct response. 1. What is the ratio of the Number of teachers of Colombia in 2004 to that in 2006?
Keep it short and to the point. 1. What is the ratio of the Number of teachers of Guatemala in 2004 to that in 2006?
Provide a succinct answer. 0.91. What is the ratio of the Number of teachers in East Asia (developing only) in 2005 to that in 2006?
Make the answer very short. 0.96. What is the ratio of the Number of teachers in Guatemala in 2005 to that in 2006?
Offer a very short reply. 0.96. What is the difference between the highest and the second highest Number of teachers of East Asia (developing only)?
Your response must be concise. 3.58e+05. What is the difference between the highest and the second highest Number of teachers of Europe(developing only)?
Offer a very short reply. 1.77e+04. What is the difference between the highest and the second highest Number of teachers of Colombia?
Your answer should be very brief. 1.44e+04. What is the difference between the highest and the second highest Number of teachers in Guatemala?
Provide a short and direct response. 2031. What is the difference between the highest and the lowest Number of teachers in East Asia (developing only)?
Provide a succinct answer. 1.67e+06. What is the difference between the highest and the lowest Number of teachers in Europe(developing only)?
Provide a short and direct response. 9.61e+04. What is the difference between the highest and the lowest Number of teachers in Colombia?
Offer a terse response. 3.61e+04. What is the difference between the highest and the lowest Number of teachers in Guatemala?
Offer a terse response. 1.71e+04. 